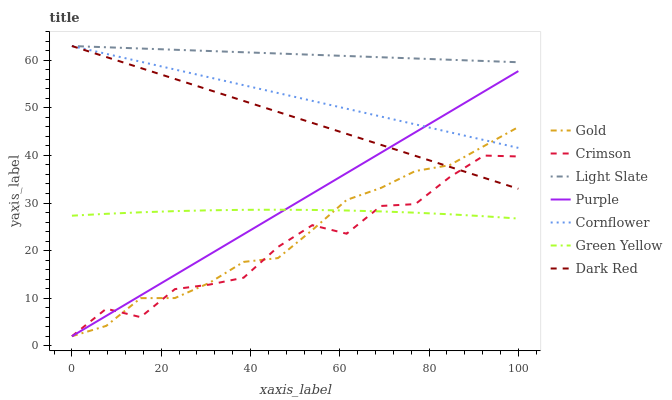Does Crimson have the minimum area under the curve?
Answer yes or no. Yes. Does Light Slate have the maximum area under the curve?
Answer yes or no. Yes. Does Gold have the minimum area under the curve?
Answer yes or no. No. Does Gold have the maximum area under the curve?
Answer yes or no. No. Is Dark Red the smoothest?
Answer yes or no. Yes. Is Crimson the roughest?
Answer yes or no. Yes. Is Gold the smoothest?
Answer yes or no. No. Is Gold the roughest?
Answer yes or no. No. Does Light Slate have the lowest value?
Answer yes or no. No. Does Dark Red have the highest value?
Answer yes or no. Yes. Does Gold have the highest value?
Answer yes or no. No. Is Green Yellow less than Dark Red?
Answer yes or no. Yes. Is Cornflower greater than Crimson?
Answer yes or no. Yes. Does Cornflower intersect Gold?
Answer yes or no. Yes. Is Cornflower less than Gold?
Answer yes or no. No. Is Cornflower greater than Gold?
Answer yes or no. No. Does Green Yellow intersect Dark Red?
Answer yes or no. No. 